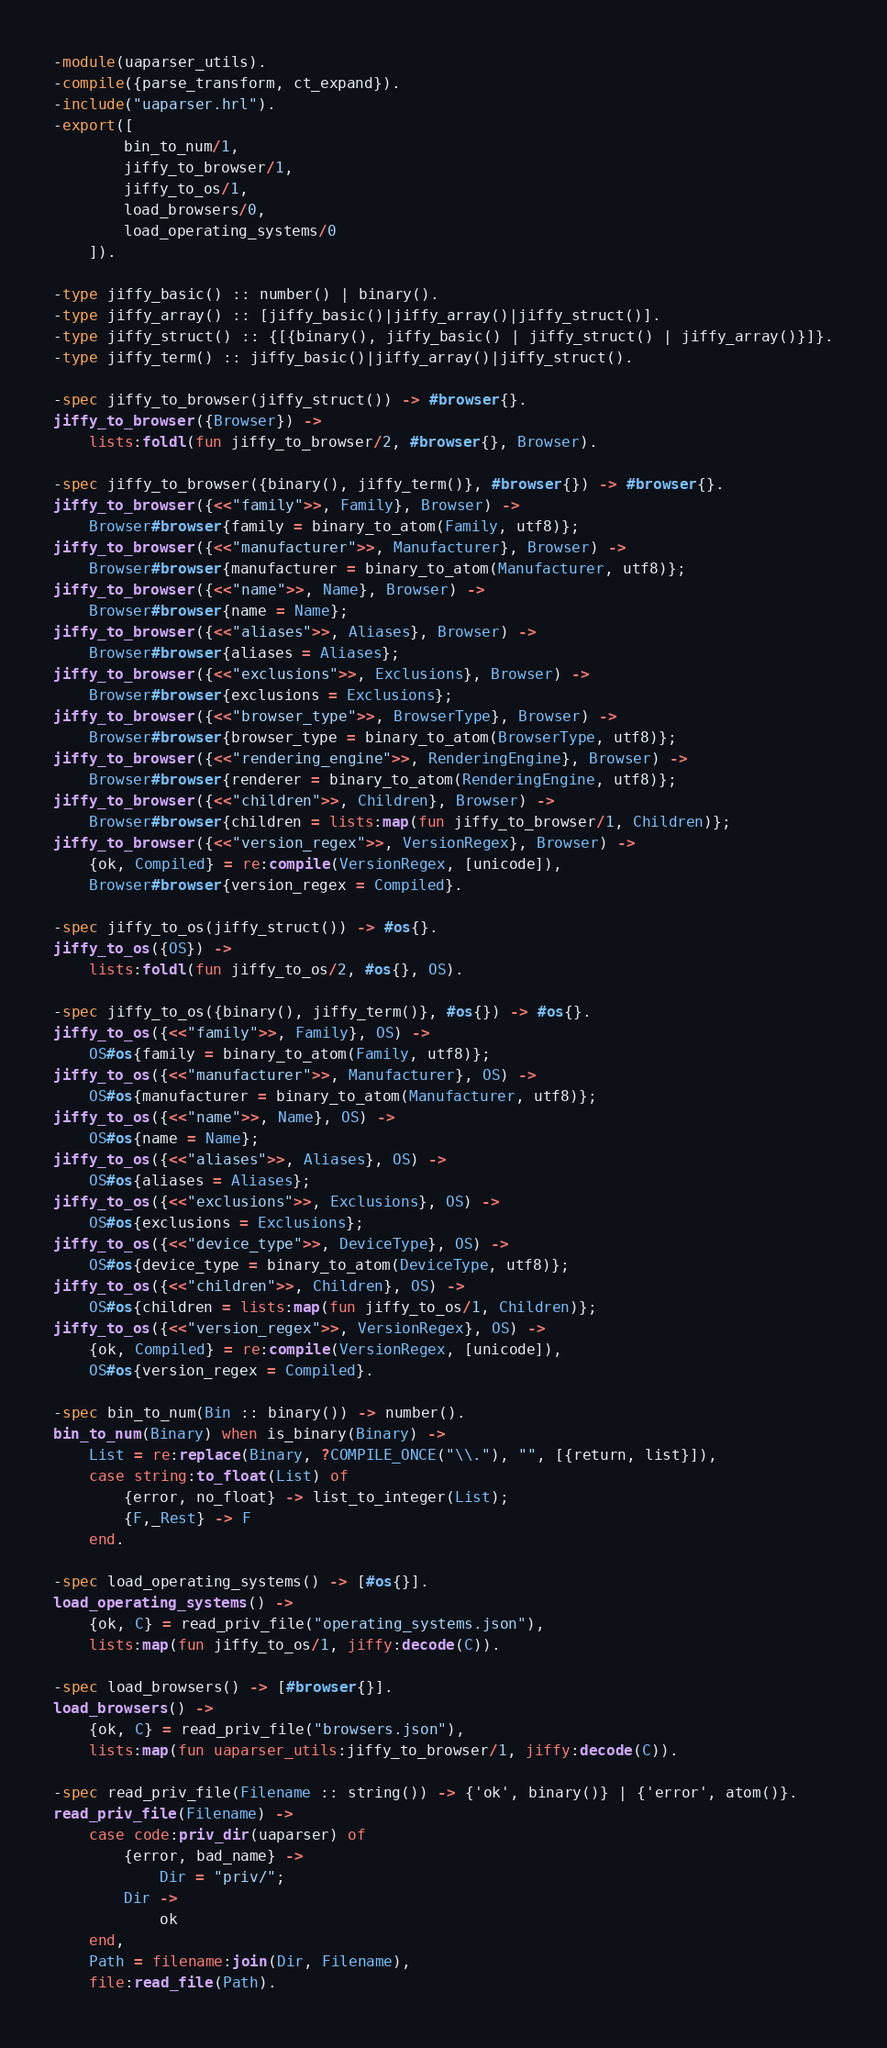Convert code to text. <code><loc_0><loc_0><loc_500><loc_500><_Erlang_>-module(uaparser_utils).
-compile({parse_transform, ct_expand}).
-include("uaparser.hrl").
-export([
        bin_to_num/1,
        jiffy_to_browser/1,
        jiffy_to_os/1,
        load_browsers/0,
        load_operating_systems/0
    ]).

-type jiffy_basic() :: number() | binary().
-type jiffy_array() :: [jiffy_basic()|jiffy_array()|jiffy_struct()].
-type jiffy_struct() :: {[{binary(), jiffy_basic() | jiffy_struct() | jiffy_array()}]}.
-type jiffy_term() :: jiffy_basic()|jiffy_array()|jiffy_struct().

-spec jiffy_to_browser(jiffy_struct()) -> #browser{}.
jiffy_to_browser({Browser}) ->
    lists:foldl(fun jiffy_to_browser/2, #browser{}, Browser).

-spec jiffy_to_browser({binary(), jiffy_term()}, #browser{}) -> #browser{}.
jiffy_to_browser({<<"family">>, Family}, Browser) ->
    Browser#browser{family = binary_to_atom(Family, utf8)};
jiffy_to_browser({<<"manufacturer">>, Manufacturer}, Browser) ->
    Browser#browser{manufacturer = binary_to_atom(Manufacturer, utf8)};
jiffy_to_browser({<<"name">>, Name}, Browser) ->
    Browser#browser{name = Name};
jiffy_to_browser({<<"aliases">>, Aliases}, Browser) ->
    Browser#browser{aliases = Aliases};
jiffy_to_browser({<<"exclusions">>, Exclusions}, Browser) ->
    Browser#browser{exclusions = Exclusions};
jiffy_to_browser({<<"browser_type">>, BrowserType}, Browser) ->
    Browser#browser{browser_type = binary_to_atom(BrowserType, utf8)};
jiffy_to_browser({<<"rendering_engine">>, RenderingEngine}, Browser) ->
    Browser#browser{renderer = binary_to_atom(RenderingEngine, utf8)};
jiffy_to_browser({<<"children">>, Children}, Browser) ->
    Browser#browser{children = lists:map(fun jiffy_to_browser/1, Children)};
jiffy_to_browser({<<"version_regex">>, VersionRegex}, Browser) ->
    {ok, Compiled} = re:compile(VersionRegex, [unicode]),
    Browser#browser{version_regex = Compiled}.

-spec jiffy_to_os(jiffy_struct()) -> #os{}.
jiffy_to_os({OS}) ->
    lists:foldl(fun jiffy_to_os/2, #os{}, OS).

-spec jiffy_to_os({binary(), jiffy_term()}, #os{}) -> #os{}.
jiffy_to_os({<<"family">>, Family}, OS) ->
    OS#os{family = binary_to_atom(Family, utf8)};
jiffy_to_os({<<"manufacturer">>, Manufacturer}, OS) ->
    OS#os{manufacturer = binary_to_atom(Manufacturer, utf8)};
jiffy_to_os({<<"name">>, Name}, OS) ->
    OS#os{name = Name};
jiffy_to_os({<<"aliases">>, Aliases}, OS) ->
    OS#os{aliases = Aliases};
jiffy_to_os({<<"exclusions">>, Exclusions}, OS) ->
    OS#os{exclusions = Exclusions};
jiffy_to_os({<<"device_type">>, DeviceType}, OS) ->
    OS#os{device_type = binary_to_atom(DeviceType, utf8)};
jiffy_to_os({<<"children">>, Children}, OS) ->
    OS#os{children = lists:map(fun jiffy_to_os/1, Children)};
jiffy_to_os({<<"version_regex">>, VersionRegex}, OS) ->
    {ok, Compiled} = re:compile(VersionRegex, [unicode]),
    OS#os{version_regex = Compiled}.

-spec bin_to_num(Bin :: binary()) -> number().
bin_to_num(Binary) when is_binary(Binary) ->
    List = re:replace(Binary, ?COMPILE_ONCE("\\."), "", [{return, list}]),
    case string:to_float(List) of
        {error, no_float} -> list_to_integer(List);
        {F,_Rest} -> F
    end.

-spec load_operating_systems() -> [#os{}].
load_operating_systems() ->
    {ok, C} = read_priv_file("operating_systems.json"),
    lists:map(fun jiffy_to_os/1, jiffy:decode(C)).

-spec load_browsers() -> [#browser{}].
load_browsers() ->
    {ok, C} = read_priv_file("browsers.json"),
    lists:map(fun uaparser_utils:jiffy_to_browser/1, jiffy:decode(C)).

-spec read_priv_file(Filename :: string()) -> {'ok', binary()} | {'error', atom()}.
read_priv_file(Filename) ->
    case code:priv_dir(uaparser) of
        {error, bad_name} ->
            Dir = "priv/";
        Dir ->
            ok
    end,
    Path = filename:join(Dir, Filename),
    file:read_file(Path).
</code> 